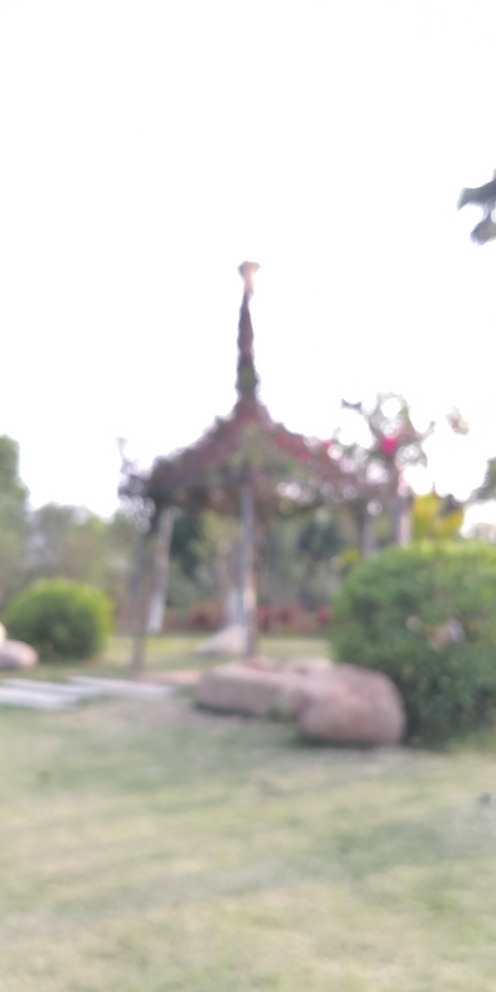Is the focus issue serious?
A. Yes
B. No The focus issue in the image is quite serious, as the blurriness prevents clear visibility of the details. A crisper image would allow for better interpretation of the scene, including whatever subject is supposed to be the center of attention. 